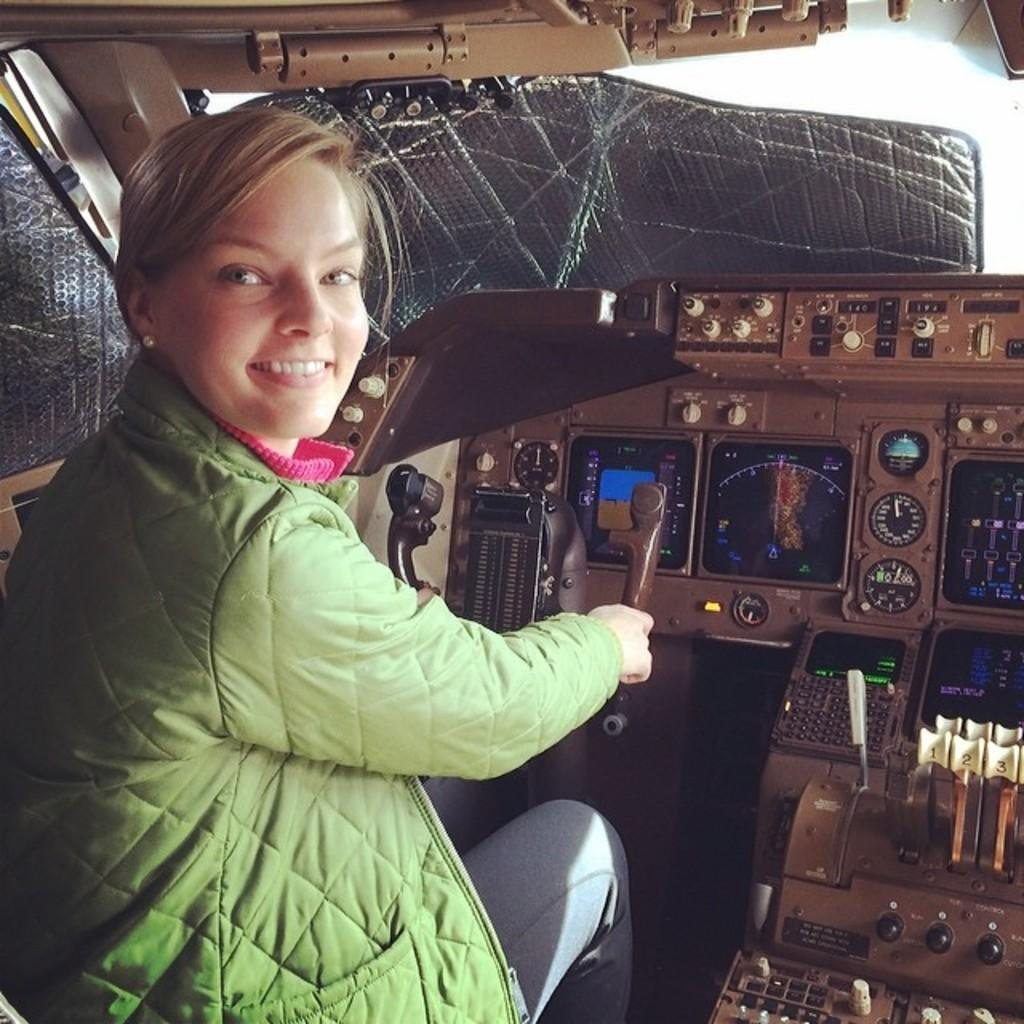Who is the main subject in the image? There is a woman in the image. What is the woman wearing? The woman is wearing a green jacket. What is the woman doing in the image? The woman is sitting on a seat and smiling. What can be seen in front of the woman? There are items in front of the woman. Can you see a beam of light shining on the woman in the image? There is no beam of light present in the image. Is the woman standing near a river in the image? There is no river present in the image. 